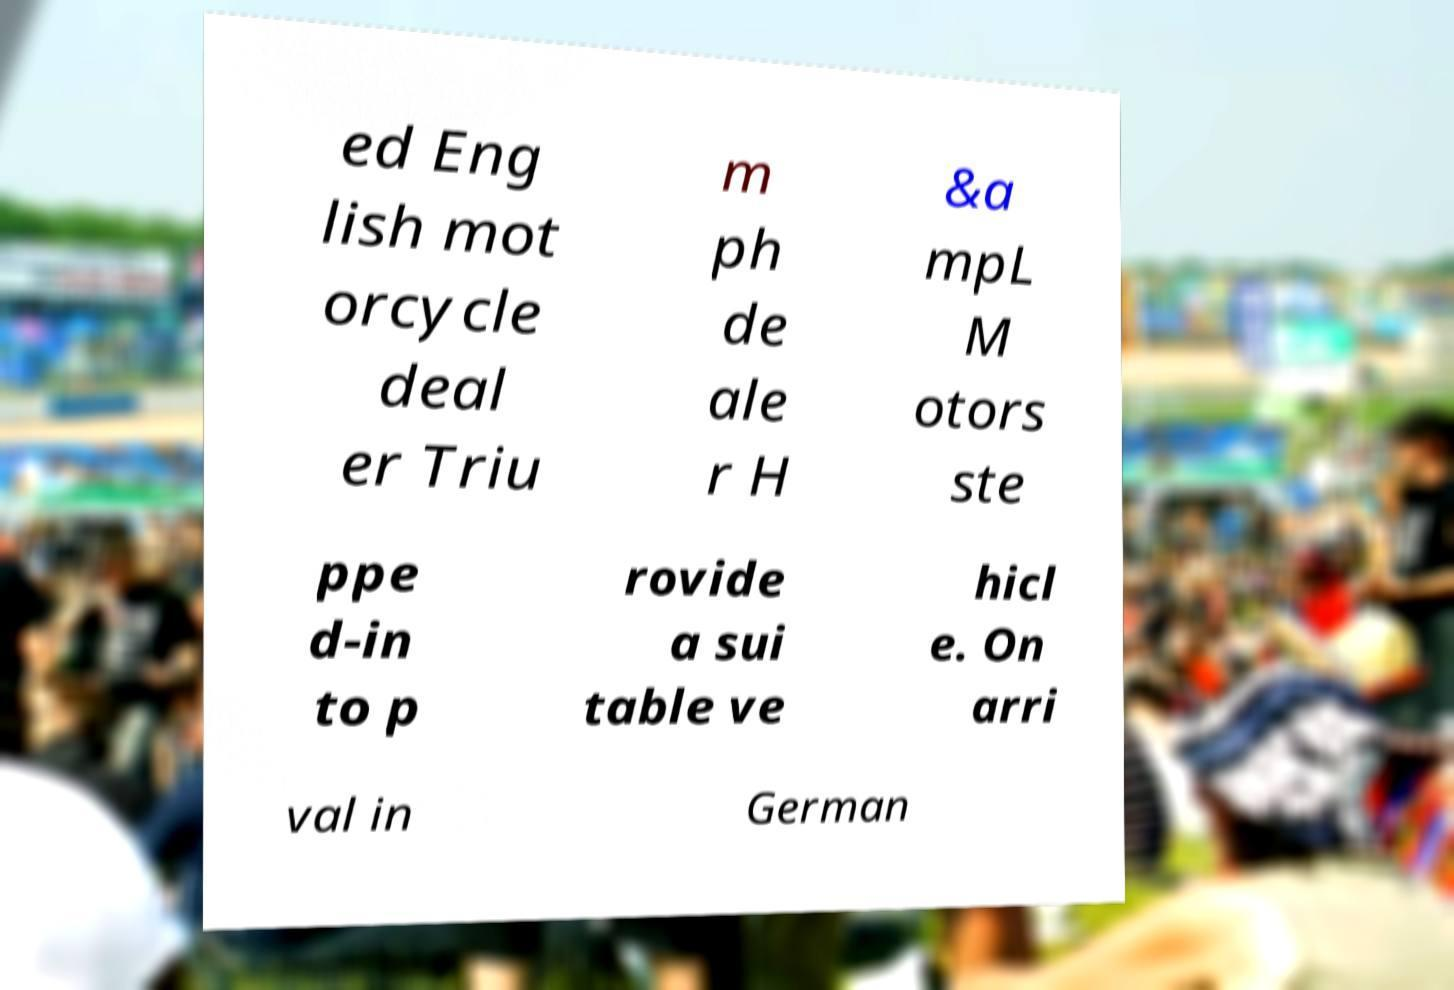Can you accurately transcribe the text from the provided image for me? ed Eng lish mot orcycle deal er Triu m ph de ale r H &a mpL M otors ste ppe d-in to p rovide a sui table ve hicl e. On arri val in German 